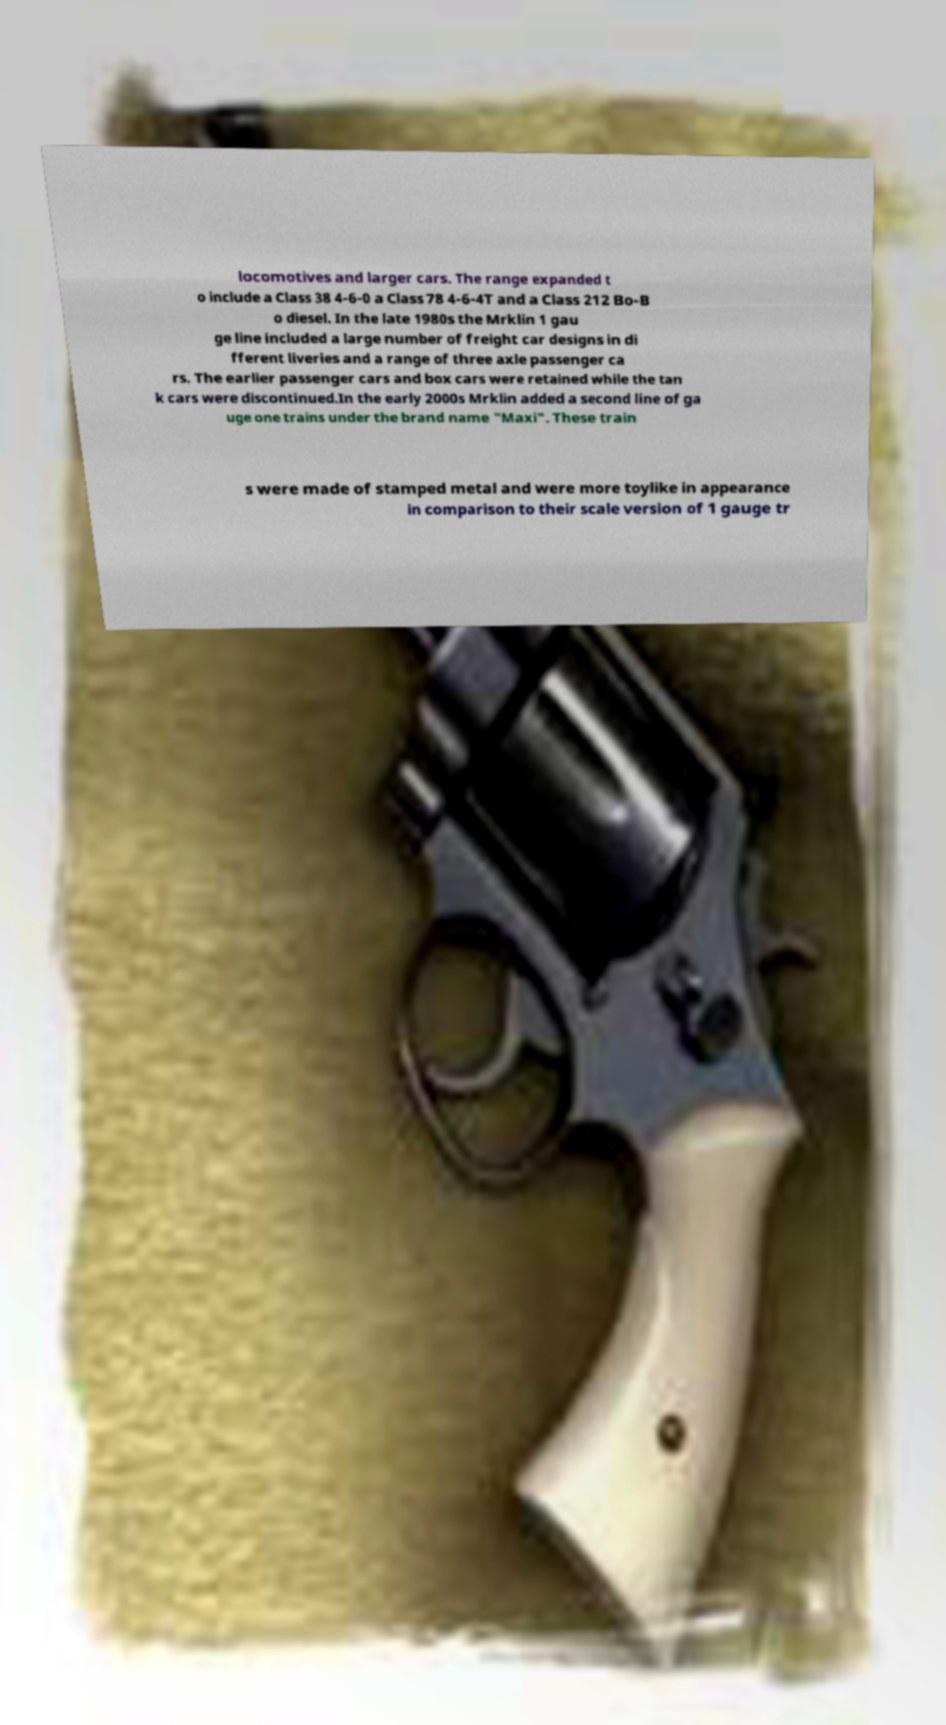Please identify and transcribe the text found in this image. locomotives and larger cars. The range expanded t o include a Class 38 4-6-0 a Class 78 4-6-4T and a Class 212 Bo-B o diesel. In the late 1980s the Mrklin 1 gau ge line included a large number of freight car designs in di fferent liveries and a range of three axle passenger ca rs. The earlier passenger cars and box cars were retained while the tan k cars were discontinued.In the early 2000s Mrklin added a second line of ga uge one trains under the brand name "Maxi". These train s were made of stamped metal and were more toylike in appearance in comparison to their scale version of 1 gauge tr 